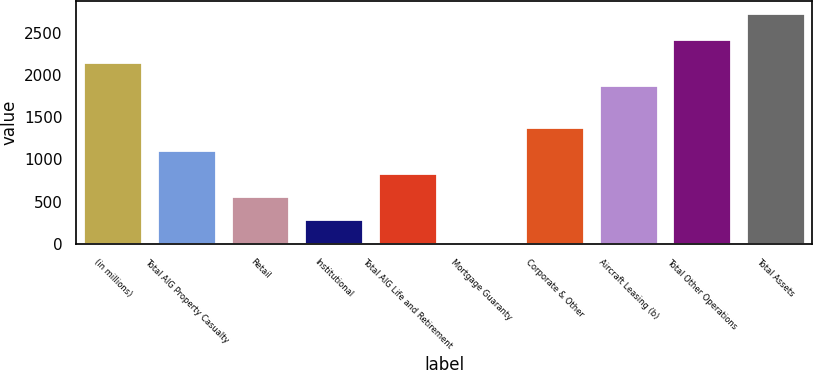Convert chart to OTSL. <chart><loc_0><loc_0><loc_500><loc_500><bar_chart><fcel>(in millions)<fcel>Total AIG Property Casualty<fcel>Retail<fcel>Institutional<fcel>Total AIG Life and Retirement<fcel>Mortgage Guaranty<fcel>Corporate & Other<fcel>Aircraft Leasing (b)<fcel>Total Other Operations<fcel>Total Assets<nl><fcel>2153.7<fcel>1107.8<fcel>566.4<fcel>295.7<fcel>837.1<fcel>25<fcel>1378.5<fcel>1883<fcel>2424.4<fcel>2732<nl></chart> 